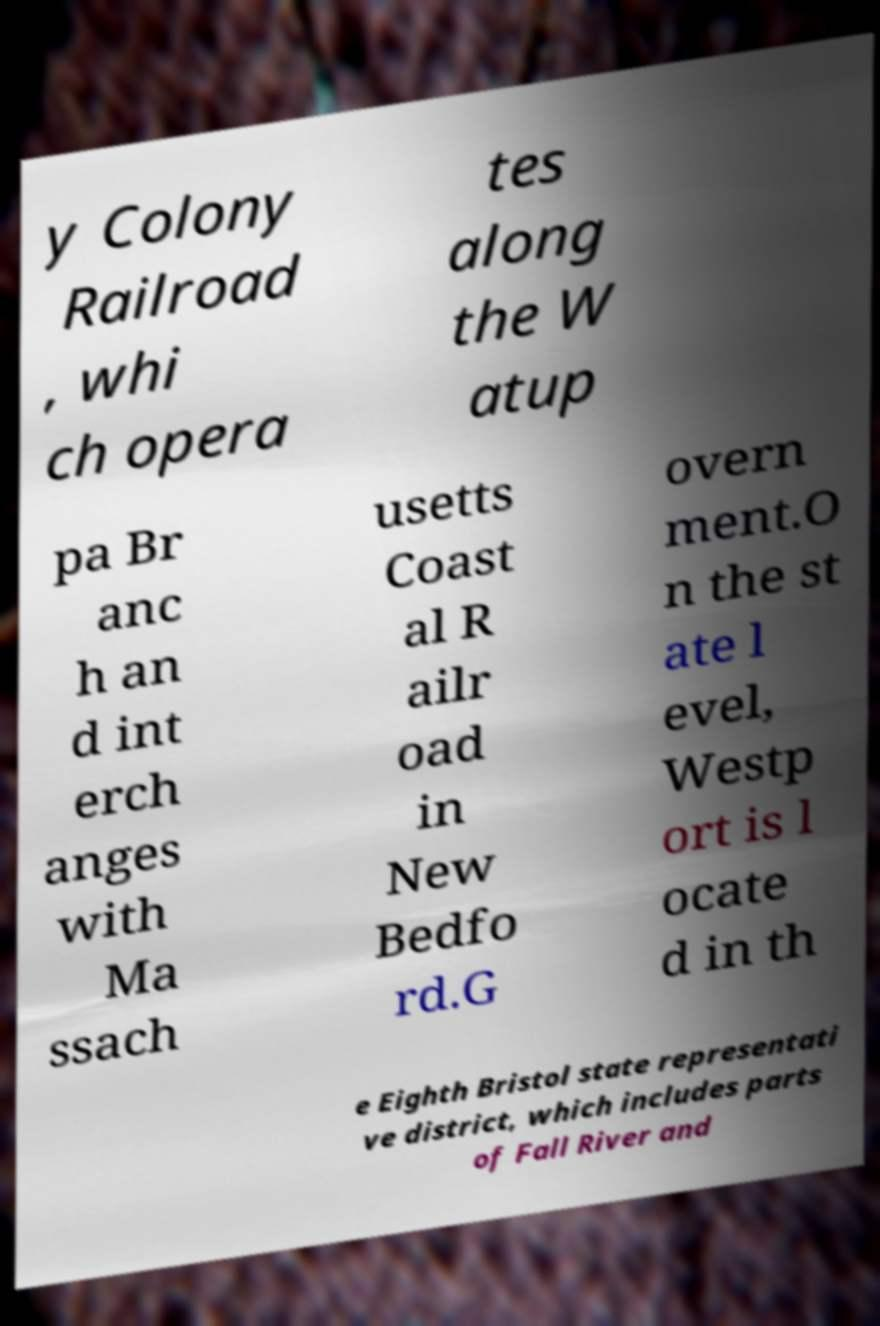What messages or text are displayed in this image? I need them in a readable, typed format. y Colony Railroad , whi ch opera tes along the W atup pa Br anc h an d int erch anges with Ma ssach usetts Coast al R ailr oad in New Bedfo rd.G overn ment.O n the st ate l evel, Westp ort is l ocate d in th e Eighth Bristol state representati ve district, which includes parts of Fall River and 